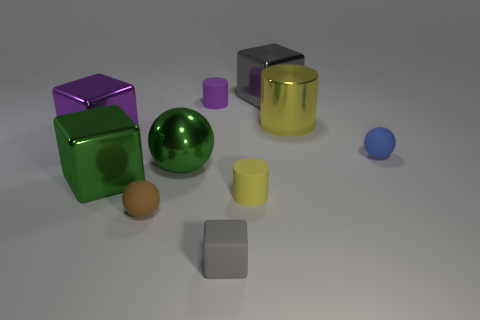What colors are represented by the objects, and do any two objects share the same color? The objects come in various colors including purple, green, silver, yellow, blue, and brown. No two objects share the exact same shade or color. 